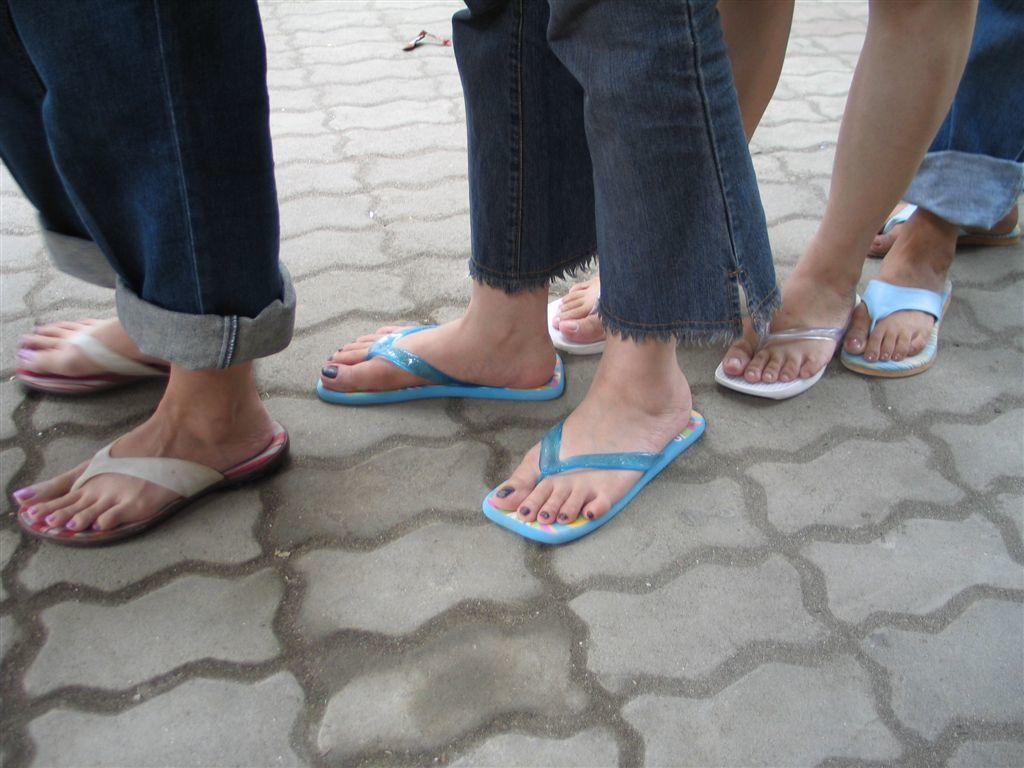What body parts are visible in the image? There are persons' legs visible in the image. What are the persons wearing on their feet? The persons are wearing footwear. What type of joke is being told by the person holding the drink in the image? There is no person holding a drink in the image, nor is there any indication of a joke being told. 